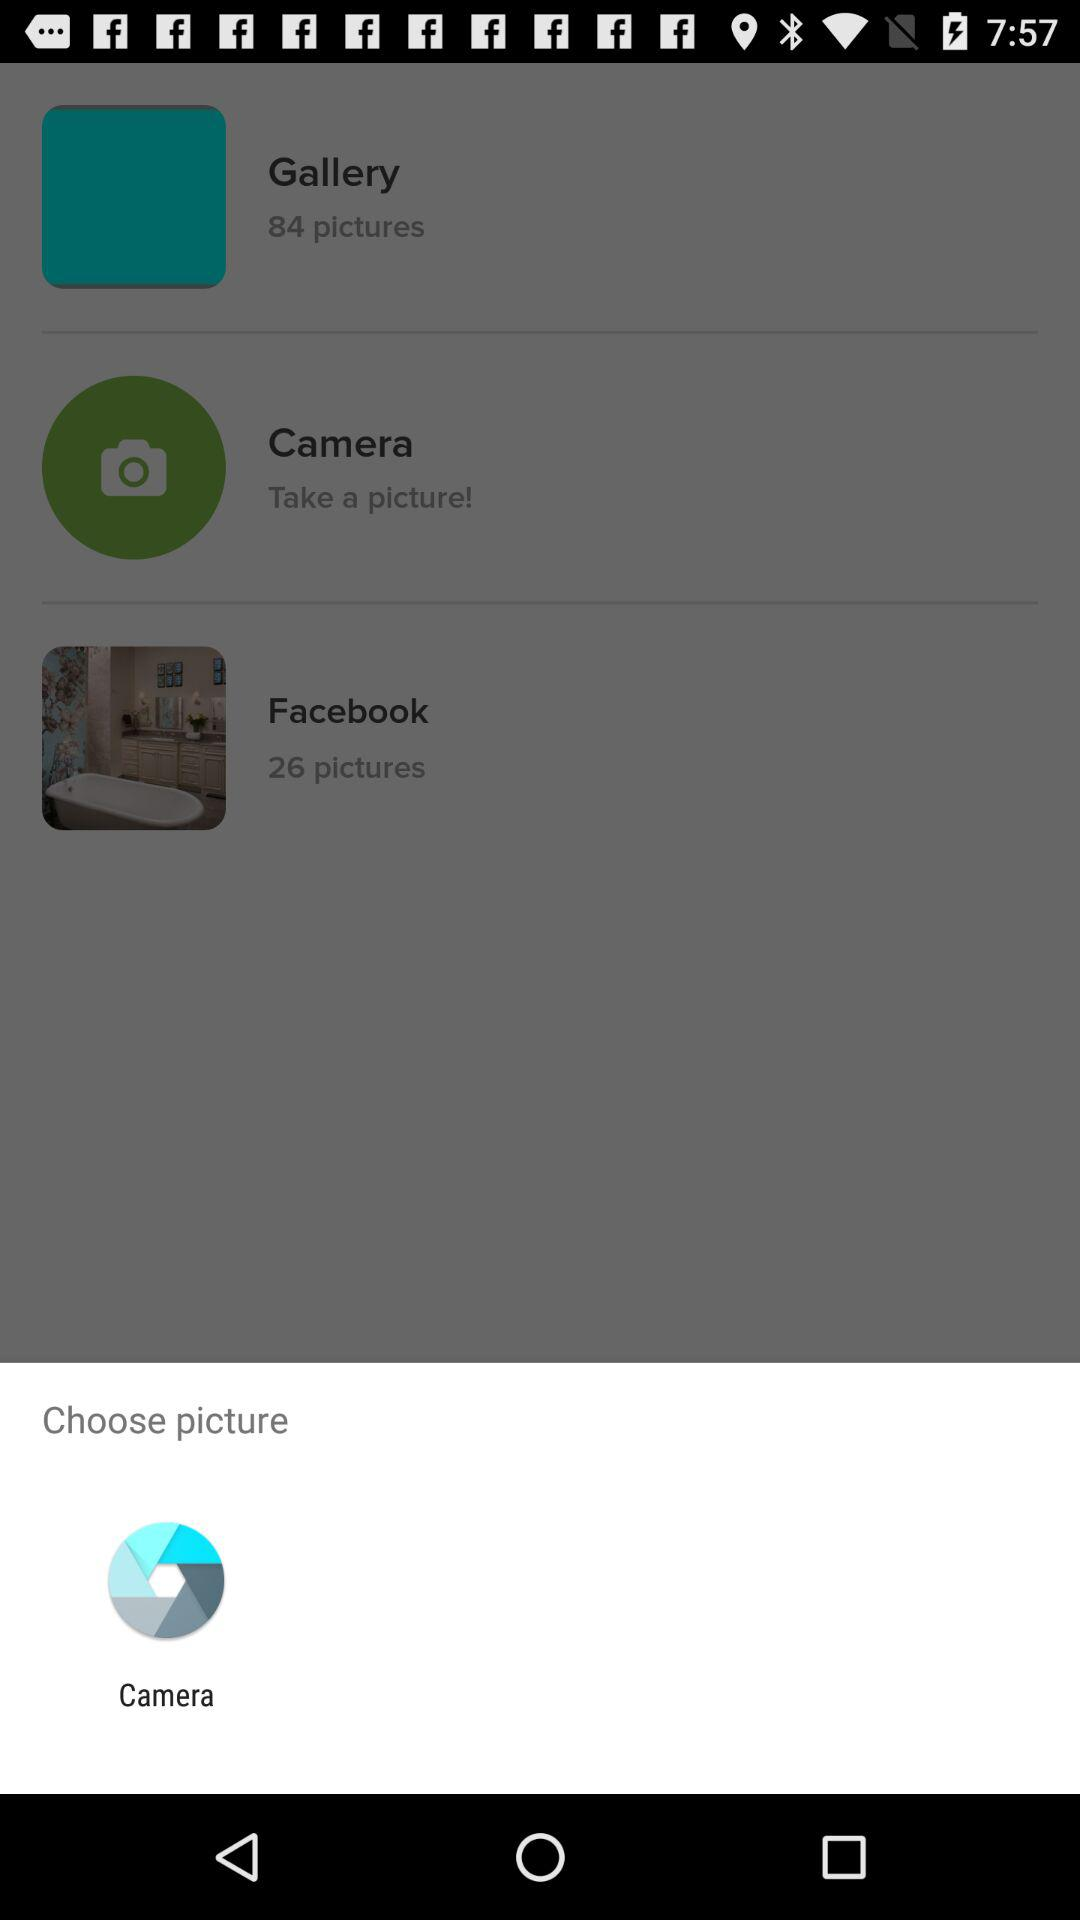How many pictures are in the two albums combined?
Answer the question using a single word or phrase. 110 